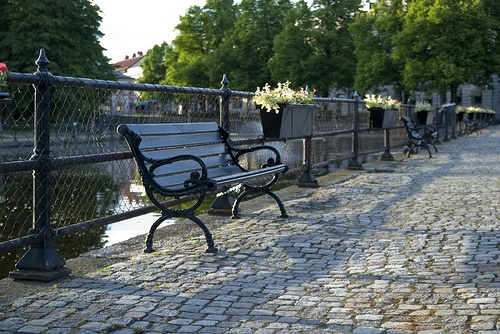Describe the objects in this image and their specific colors. I can see bench in black, gray, and blue tones, potted plant in black, purple, ivory, and olive tones, bench in black, gray, and darkblue tones, potted plant in black, gray, and darkgray tones, and bench in black, gray, and darkblue tones in this image. 